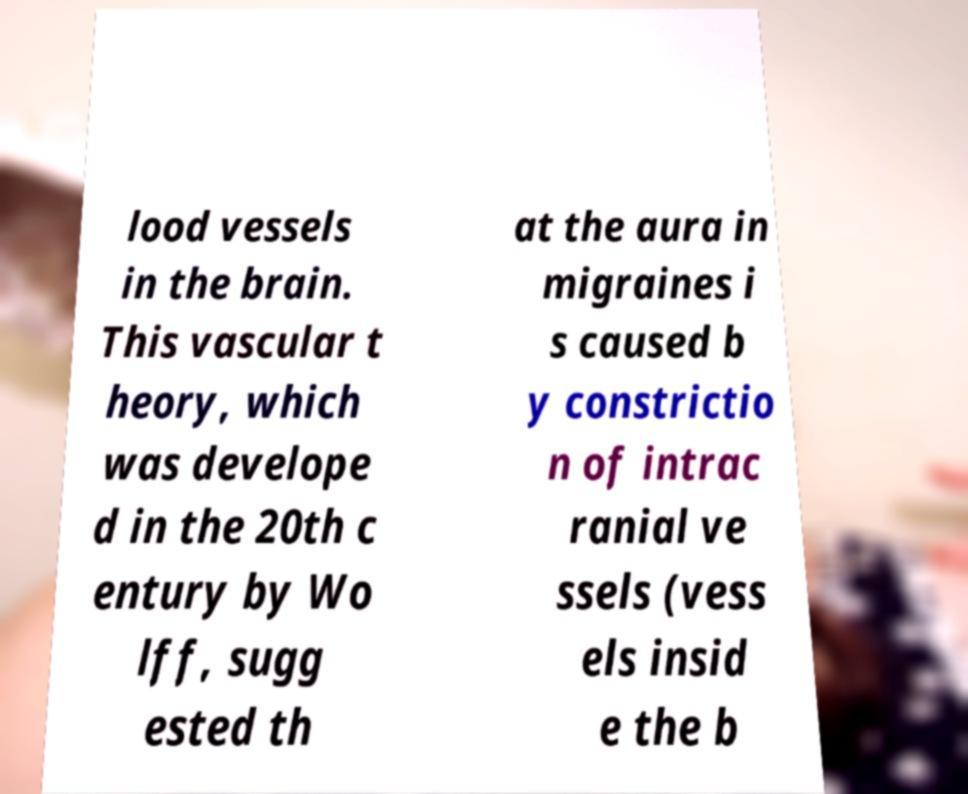Can you accurately transcribe the text from the provided image for me? lood vessels in the brain. This vascular t heory, which was develope d in the 20th c entury by Wo lff, sugg ested th at the aura in migraines i s caused b y constrictio n of intrac ranial ve ssels (vess els insid e the b 